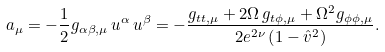Convert formula to latex. <formula><loc_0><loc_0><loc_500><loc_500>a _ { \mu } = - { \frac { 1 } { 2 } } g _ { \alpha \beta , \mu } \, u ^ { \alpha } \, u ^ { \beta } = - \frac { g _ { t t , \mu } + 2 \Omega \, g _ { t \phi , \mu } + \Omega ^ { 2 } g _ { \phi \phi , \mu } } { 2 e ^ { 2 \nu } \left ( 1 - \hat { v } ^ { 2 } \right ) } .</formula> 